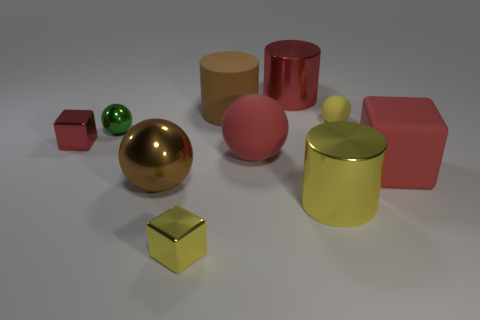There is a big cylinder that is the same color as the big cube; what material is it?
Your answer should be compact. Metal. There is a brown thing in front of the tiny metal block behind the small yellow shiny thing; what size is it?
Give a very brief answer. Large. Are there any big blue cubes that have the same material as the yellow sphere?
Provide a succinct answer. No. There is a yellow object that is the same size as the brown cylinder; what is it made of?
Offer a very short reply. Metal. There is a big metal cylinder that is behind the tiny rubber object; is its color the same as the tiny block behind the large yellow metallic cylinder?
Offer a very short reply. Yes. There is a red block behind the large cube; is there a tiny metal thing that is to the right of it?
Provide a short and direct response. Yes. There is a big red thing behind the large brown matte object; is it the same shape as the small yellow thing that is right of the big brown rubber thing?
Offer a very short reply. No. Is the big brown thing that is left of the large brown matte cylinder made of the same material as the red thing on the right side of the tiny yellow matte ball?
Offer a very short reply. No. What material is the cube that is on the right side of the shiny cylinder that is on the right side of the big red metal cylinder made of?
Ensure brevity in your answer.  Rubber. What is the shape of the red rubber object that is behind the large red thing on the right side of the shiny thing that is to the right of the big red cylinder?
Make the answer very short. Sphere. 